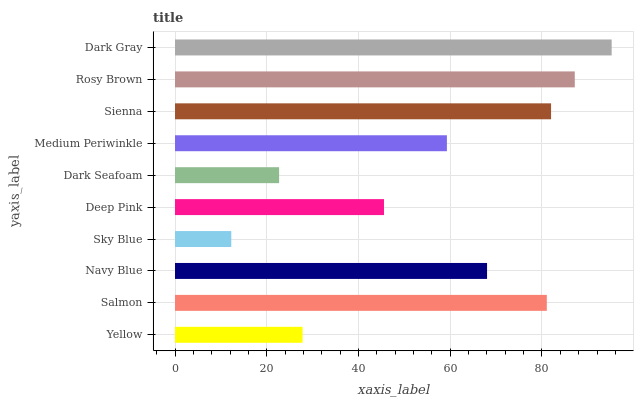Is Sky Blue the minimum?
Answer yes or no. Yes. Is Dark Gray the maximum?
Answer yes or no. Yes. Is Salmon the minimum?
Answer yes or no. No. Is Salmon the maximum?
Answer yes or no. No. Is Salmon greater than Yellow?
Answer yes or no. Yes. Is Yellow less than Salmon?
Answer yes or no. Yes. Is Yellow greater than Salmon?
Answer yes or no. No. Is Salmon less than Yellow?
Answer yes or no. No. Is Navy Blue the high median?
Answer yes or no. Yes. Is Medium Periwinkle the low median?
Answer yes or no. Yes. Is Medium Periwinkle the high median?
Answer yes or no. No. Is Yellow the low median?
Answer yes or no. No. 